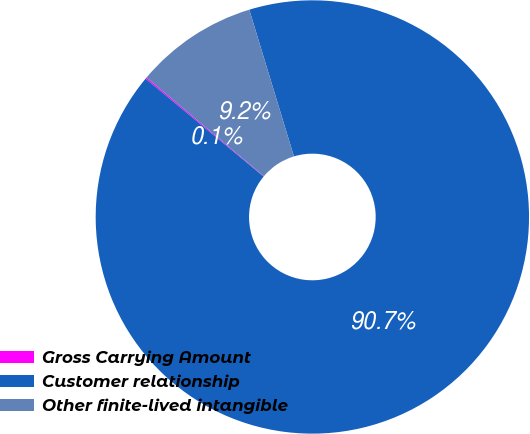Convert chart. <chart><loc_0><loc_0><loc_500><loc_500><pie_chart><fcel>Gross Carrying Amount<fcel>Customer relationship<fcel>Other finite-lived intangible<nl><fcel>0.11%<fcel>90.71%<fcel>9.17%<nl></chart> 